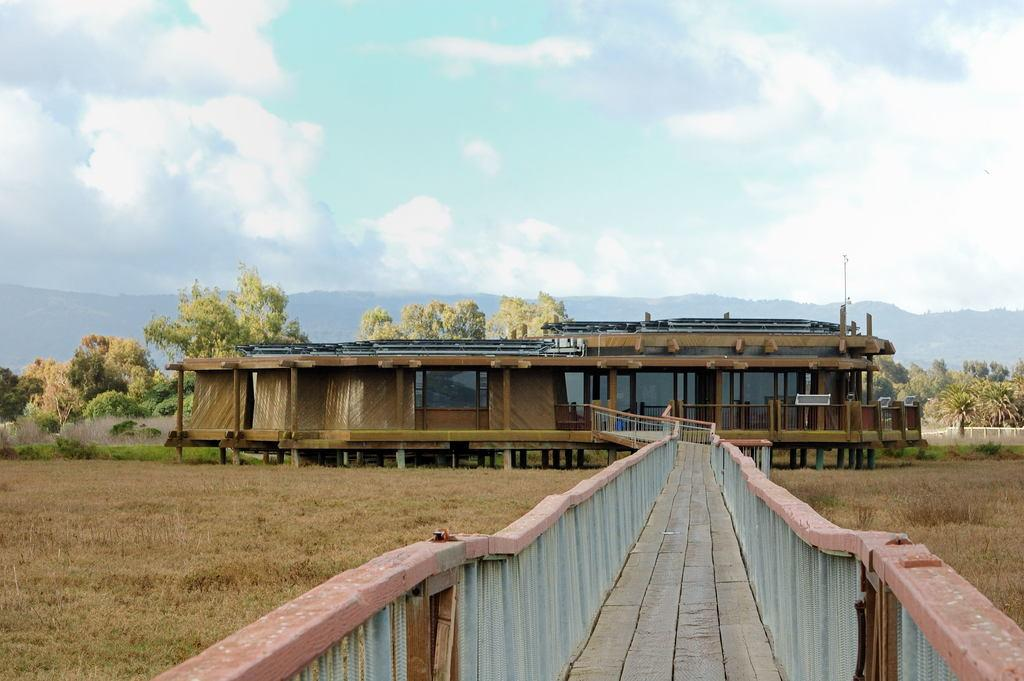What type of path is visible in the image? There is a wooden path in the image. What structure can be seen in the background of the image? There is a wooden house in the background of the image. What color are the trees in the image? The trees in the image have green color. What colors are visible in the sky in the image? The sky is blue and white in color. Where is the tank located in the image? There is no tank present in the image. What shape is the wooden house in the image? The shape of the wooden house is not mentioned in the provided facts, so we cannot determine its shape from the image. 